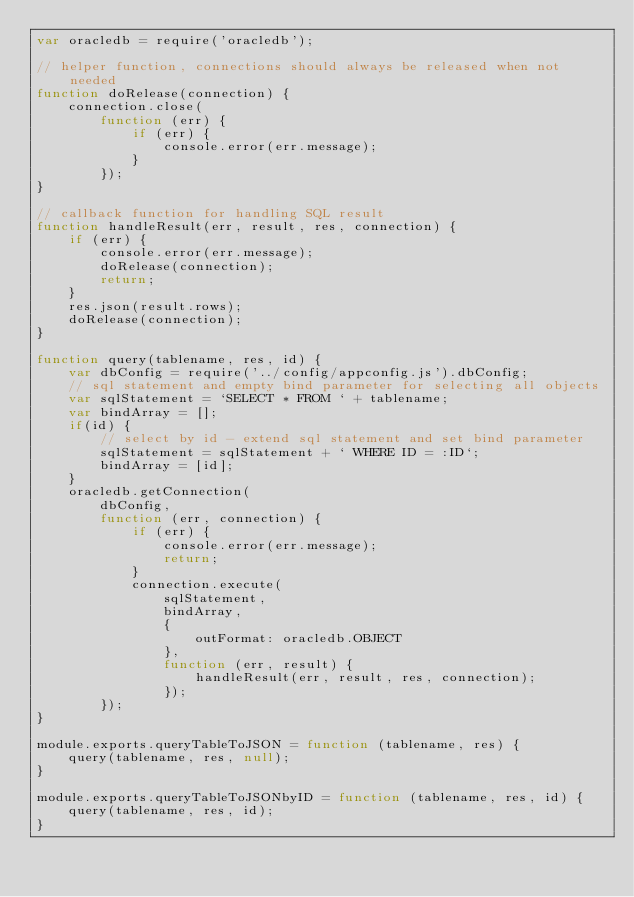<code> <loc_0><loc_0><loc_500><loc_500><_JavaScript_>var oracledb = require('oracledb');

// helper function, connections should always be released when not needed
function doRelease(connection) {
    connection.close(
        function (err) {
            if (err) {
                console.error(err.message);
            }
        });
}

// callback function for handling SQL result
function handleResult(err, result, res, connection) {
    if (err) {
        console.error(err.message);
        doRelease(connection);
        return;
    }
    res.json(result.rows);
    doRelease(connection);
}

function query(tablename, res, id) {
    var dbConfig = require('../config/appconfig.js').dbConfig;
    // sql statement and empty bind parameter for selecting all objects
    var sqlStatement = `SELECT * FROM ` + tablename;
    var bindArray = [];
    if(id) {
        // select by id - extend sql statement and set bind parameter
        sqlStatement = sqlStatement + ` WHERE ID = :ID`;
        bindArray = [id];
    } 
    oracledb.getConnection(
        dbConfig,
        function (err, connection) {
            if (err) {
                console.error(err.message);
                return;
            }
            connection.execute(
                sqlStatement,
                bindArray,
                {
                    outFormat: oracledb.OBJECT
                },
                function (err, result) {
                    handleResult(err, result, res, connection);
                });
        });
}

module.exports.queryTableToJSON = function (tablename, res) {
    query(tablename, res, null);
}

module.exports.queryTableToJSONbyID = function (tablename, res, id) {
    query(tablename, res, id);
}</code> 